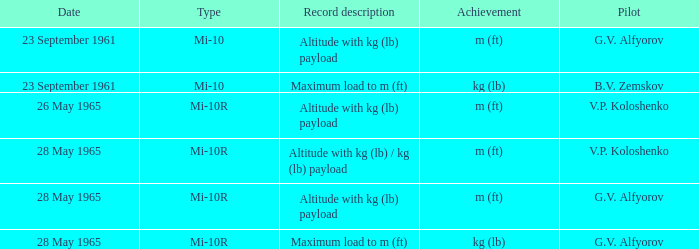Pilot of g.v. alfyorov, and a Record description of altitude with kg (lb) payload, and a Type of mi-10 involved what date? 23 September 1961. 